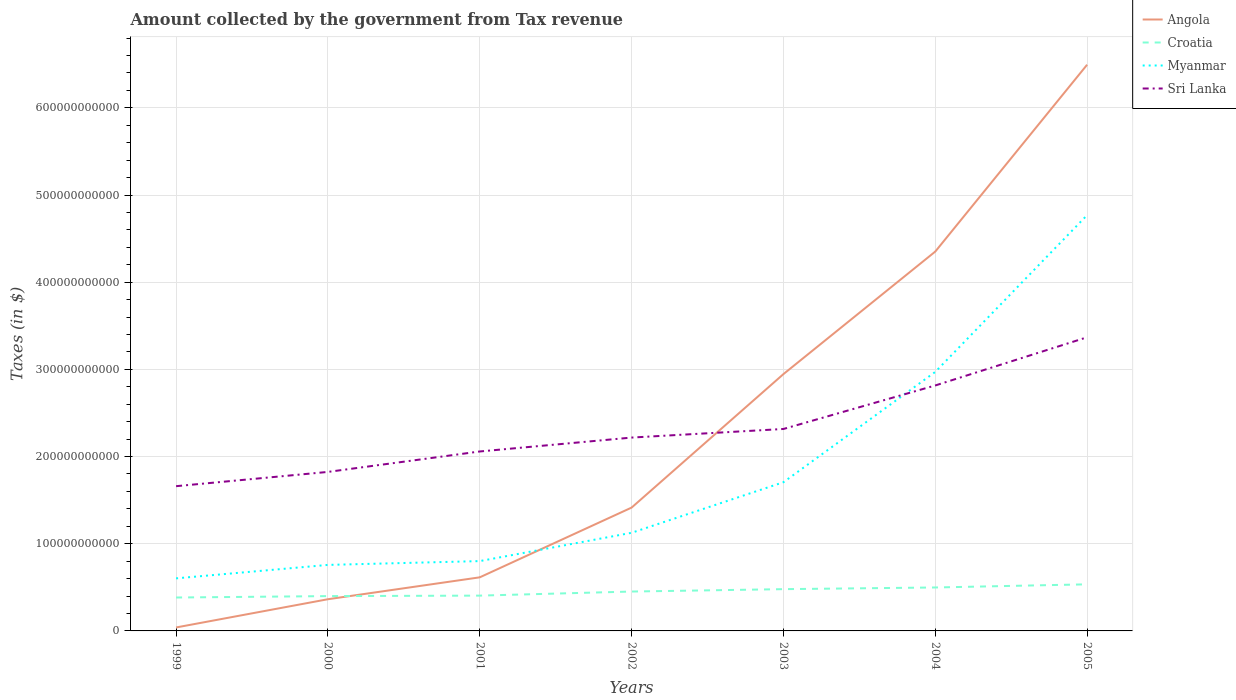How many different coloured lines are there?
Your answer should be compact. 4. Is the number of lines equal to the number of legend labels?
Offer a very short reply. Yes. Across all years, what is the maximum amount collected by the government from tax revenue in Angola?
Your answer should be compact. 3.97e+09. What is the total amount collected by the government from tax revenue in Angola in the graph?
Your answer should be very brief. -3.99e+11. What is the difference between the highest and the second highest amount collected by the government from tax revenue in Croatia?
Offer a terse response. 1.51e+1. What is the difference between the highest and the lowest amount collected by the government from tax revenue in Sri Lanka?
Provide a short and direct response. 2. Is the amount collected by the government from tax revenue in Sri Lanka strictly greater than the amount collected by the government from tax revenue in Croatia over the years?
Offer a terse response. No. How many years are there in the graph?
Make the answer very short. 7. What is the difference between two consecutive major ticks on the Y-axis?
Provide a short and direct response. 1.00e+11. Does the graph contain grids?
Give a very brief answer. Yes. How are the legend labels stacked?
Your answer should be compact. Vertical. What is the title of the graph?
Make the answer very short. Amount collected by the government from Tax revenue. Does "Norway" appear as one of the legend labels in the graph?
Offer a terse response. No. What is the label or title of the X-axis?
Make the answer very short. Years. What is the label or title of the Y-axis?
Provide a succinct answer. Taxes (in $). What is the Taxes (in $) in Angola in 1999?
Offer a terse response. 3.97e+09. What is the Taxes (in $) in Croatia in 1999?
Provide a short and direct response. 3.83e+1. What is the Taxes (in $) in Myanmar in 1999?
Make the answer very short. 6.03e+1. What is the Taxes (in $) in Sri Lanka in 1999?
Your answer should be compact. 1.66e+11. What is the Taxes (in $) of Angola in 2000?
Your answer should be compact. 3.64e+1. What is the Taxes (in $) in Croatia in 2000?
Your response must be concise. 3.99e+1. What is the Taxes (in $) in Myanmar in 2000?
Make the answer very short. 7.57e+1. What is the Taxes (in $) of Sri Lanka in 2000?
Provide a short and direct response. 1.82e+11. What is the Taxes (in $) in Angola in 2001?
Your answer should be very brief. 6.15e+1. What is the Taxes (in $) in Croatia in 2001?
Make the answer very short. 4.05e+1. What is the Taxes (in $) of Myanmar in 2001?
Give a very brief answer. 8.01e+1. What is the Taxes (in $) of Sri Lanka in 2001?
Your answer should be compact. 2.06e+11. What is the Taxes (in $) in Angola in 2002?
Provide a short and direct response. 1.41e+11. What is the Taxes (in $) of Croatia in 2002?
Offer a terse response. 4.52e+1. What is the Taxes (in $) of Myanmar in 2002?
Keep it short and to the point. 1.13e+11. What is the Taxes (in $) of Sri Lanka in 2002?
Keep it short and to the point. 2.22e+11. What is the Taxes (in $) of Angola in 2003?
Give a very brief answer. 2.95e+11. What is the Taxes (in $) of Croatia in 2003?
Your answer should be compact. 4.79e+1. What is the Taxes (in $) in Myanmar in 2003?
Make the answer very short. 1.71e+11. What is the Taxes (in $) in Sri Lanka in 2003?
Your response must be concise. 2.32e+11. What is the Taxes (in $) of Angola in 2004?
Your answer should be compact. 4.35e+11. What is the Taxes (in $) in Croatia in 2004?
Ensure brevity in your answer.  4.98e+1. What is the Taxes (in $) in Myanmar in 2004?
Your answer should be compact. 2.97e+11. What is the Taxes (in $) of Sri Lanka in 2004?
Your answer should be compact. 2.82e+11. What is the Taxes (in $) in Angola in 2005?
Provide a short and direct response. 6.49e+11. What is the Taxes (in $) in Croatia in 2005?
Your answer should be compact. 5.34e+1. What is the Taxes (in $) in Myanmar in 2005?
Give a very brief answer. 4.77e+11. What is the Taxes (in $) in Sri Lanka in 2005?
Your answer should be compact. 3.37e+11. Across all years, what is the maximum Taxes (in $) in Angola?
Offer a terse response. 6.49e+11. Across all years, what is the maximum Taxes (in $) of Croatia?
Provide a succinct answer. 5.34e+1. Across all years, what is the maximum Taxes (in $) of Myanmar?
Your answer should be very brief. 4.77e+11. Across all years, what is the maximum Taxes (in $) in Sri Lanka?
Provide a succinct answer. 3.37e+11. Across all years, what is the minimum Taxes (in $) in Angola?
Offer a very short reply. 3.97e+09. Across all years, what is the minimum Taxes (in $) in Croatia?
Ensure brevity in your answer.  3.83e+1. Across all years, what is the minimum Taxes (in $) in Myanmar?
Provide a short and direct response. 6.03e+1. Across all years, what is the minimum Taxes (in $) of Sri Lanka?
Give a very brief answer. 1.66e+11. What is the total Taxes (in $) of Angola in the graph?
Make the answer very short. 1.62e+12. What is the total Taxes (in $) in Croatia in the graph?
Provide a short and direct response. 3.15e+11. What is the total Taxes (in $) in Myanmar in the graph?
Your answer should be compact. 1.27e+12. What is the total Taxes (in $) in Sri Lanka in the graph?
Your response must be concise. 1.63e+12. What is the difference between the Taxes (in $) in Angola in 1999 and that in 2000?
Keep it short and to the point. -3.24e+1. What is the difference between the Taxes (in $) in Croatia in 1999 and that in 2000?
Your response must be concise. -1.62e+09. What is the difference between the Taxes (in $) of Myanmar in 1999 and that in 2000?
Your answer should be very brief. -1.54e+1. What is the difference between the Taxes (in $) of Sri Lanka in 1999 and that in 2000?
Keep it short and to the point. -1.64e+1. What is the difference between the Taxes (in $) in Angola in 1999 and that in 2001?
Give a very brief answer. -5.75e+1. What is the difference between the Taxes (in $) of Croatia in 1999 and that in 2001?
Offer a terse response. -2.17e+09. What is the difference between the Taxes (in $) in Myanmar in 1999 and that in 2001?
Your answer should be very brief. -1.98e+1. What is the difference between the Taxes (in $) of Sri Lanka in 1999 and that in 2001?
Offer a terse response. -3.98e+1. What is the difference between the Taxes (in $) of Angola in 1999 and that in 2002?
Offer a terse response. -1.38e+11. What is the difference between the Taxes (in $) of Croatia in 1999 and that in 2002?
Provide a succinct answer. -6.85e+09. What is the difference between the Taxes (in $) in Myanmar in 1999 and that in 2002?
Give a very brief answer. -5.23e+1. What is the difference between the Taxes (in $) in Sri Lanka in 1999 and that in 2002?
Offer a terse response. -5.58e+1. What is the difference between the Taxes (in $) of Angola in 1999 and that in 2003?
Your response must be concise. -2.91e+11. What is the difference between the Taxes (in $) in Croatia in 1999 and that in 2003?
Provide a succinct answer. -9.59e+09. What is the difference between the Taxes (in $) in Myanmar in 1999 and that in 2003?
Provide a short and direct response. -1.10e+11. What is the difference between the Taxes (in $) of Sri Lanka in 1999 and that in 2003?
Give a very brief answer. -6.56e+1. What is the difference between the Taxes (in $) of Angola in 1999 and that in 2004?
Offer a very short reply. -4.31e+11. What is the difference between the Taxes (in $) in Croatia in 1999 and that in 2004?
Keep it short and to the point. -1.15e+1. What is the difference between the Taxes (in $) in Myanmar in 1999 and that in 2004?
Give a very brief answer. -2.37e+11. What is the difference between the Taxes (in $) in Sri Lanka in 1999 and that in 2004?
Provide a short and direct response. -1.16e+11. What is the difference between the Taxes (in $) in Angola in 1999 and that in 2005?
Ensure brevity in your answer.  -6.46e+11. What is the difference between the Taxes (in $) of Croatia in 1999 and that in 2005?
Keep it short and to the point. -1.51e+1. What is the difference between the Taxes (in $) of Myanmar in 1999 and that in 2005?
Keep it short and to the point. -4.17e+11. What is the difference between the Taxes (in $) in Sri Lanka in 1999 and that in 2005?
Offer a terse response. -1.71e+11. What is the difference between the Taxes (in $) in Angola in 2000 and that in 2001?
Provide a succinct answer. -2.51e+1. What is the difference between the Taxes (in $) in Croatia in 2000 and that in 2001?
Offer a very short reply. -5.53e+08. What is the difference between the Taxes (in $) of Myanmar in 2000 and that in 2001?
Offer a terse response. -4.37e+09. What is the difference between the Taxes (in $) of Sri Lanka in 2000 and that in 2001?
Keep it short and to the point. -2.34e+1. What is the difference between the Taxes (in $) in Angola in 2000 and that in 2002?
Provide a succinct answer. -1.05e+11. What is the difference between the Taxes (in $) in Croatia in 2000 and that in 2002?
Ensure brevity in your answer.  -5.23e+09. What is the difference between the Taxes (in $) in Myanmar in 2000 and that in 2002?
Give a very brief answer. -3.68e+1. What is the difference between the Taxes (in $) in Sri Lanka in 2000 and that in 2002?
Ensure brevity in your answer.  -3.94e+1. What is the difference between the Taxes (in $) of Angola in 2000 and that in 2003?
Keep it short and to the point. -2.58e+11. What is the difference between the Taxes (in $) in Croatia in 2000 and that in 2003?
Your answer should be very brief. -7.97e+09. What is the difference between the Taxes (in $) in Myanmar in 2000 and that in 2003?
Provide a succinct answer. -9.48e+1. What is the difference between the Taxes (in $) in Sri Lanka in 2000 and that in 2003?
Keep it short and to the point. -4.93e+1. What is the difference between the Taxes (in $) in Angola in 2000 and that in 2004?
Your response must be concise. -3.99e+11. What is the difference between the Taxes (in $) in Croatia in 2000 and that in 2004?
Your answer should be compact. -9.89e+09. What is the difference between the Taxes (in $) of Myanmar in 2000 and that in 2004?
Provide a succinct answer. -2.21e+11. What is the difference between the Taxes (in $) of Sri Lanka in 2000 and that in 2004?
Offer a terse response. -9.92e+1. What is the difference between the Taxes (in $) in Angola in 2000 and that in 2005?
Make the answer very short. -6.13e+11. What is the difference between the Taxes (in $) of Croatia in 2000 and that in 2005?
Offer a terse response. -1.35e+1. What is the difference between the Taxes (in $) in Myanmar in 2000 and that in 2005?
Ensure brevity in your answer.  -4.01e+11. What is the difference between the Taxes (in $) of Sri Lanka in 2000 and that in 2005?
Give a very brief answer. -1.54e+11. What is the difference between the Taxes (in $) in Angola in 2001 and that in 2002?
Offer a terse response. -8.00e+1. What is the difference between the Taxes (in $) in Croatia in 2001 and that in 2002?
Keep it short and to the point. -4.68e+09. What is the difference between the Taxes (in $) of Myanmar in 2001 and that in 2002?
Keep it short and to the point. -3.25e+1. What is the difference between the Taxes (in $) in Sri Lanka in 2001 and that in 2002?
Ensure brevity in your answer.  -1.59e+1. What is the difference between the Taxes (in $) in Angola in 2001 and that in 2003?
Your answer should be very brief. -2.33e+11. What is the difference between the Taxes (in $) in Croatia in 2001 and that in 2003?
Provide a short and direct response. -7.42e+09. What is the difference between the Taxes (in $) of Myanmar in 2001 and that in 2003?
Your answer should be compact. -9.05e+1. What is the difference between the Taxes (in $) in Sri Lanka in 2001 and that in 2003?
Your answer should be very brief. -2.58e+1. What is the difference between the Taxes (in $) in Angola in 2001 and that in 2004?
Make the answer very short. -3.74e+11. What is the difference between the Taxes (in $) of Croatia in 2001 and that in 2004?
Your answer should be compact. -9.34e+09. What is the difference between the Taxes (in $) in Myanmar in 2001 and that in 2004?
Your answer should be compact. -2.17e+11. What is the difference between the Taxes (in $) of Sri Lanka in 2001 and that in 2004?
Give a very brief answer. -7.57e+1. What is the difference between the Taxes (in $) of Angola in 2001 and that in 2005?
Keep it short and to the point. -5.88e+11. What is the difference between the Taxes (in $) in Croatia in 2001 and that in 2005?
Ensure brevity in your answer.  -1.30e+1. What is the difference between the Taxes (in $) of Myanmar in 2001 and that in 2005?
Your answer should be very brief. -3.97e+11. What is the difference between the Taxes (in $) of Sri Lanka in 2001 and that in 2005?
Your answer should be very brief. -1.31e+11. What is the difference between the Taxes (in $) of Angola in 2002 and that in 2003?
Keep it short and to the point. -1.53e+11. What is the difference between the Taxes (in $) in Croatia in 2002 and that in 2003?
Your response must be concise. -2.74e+09. What is the difference between the Taxes (in $) in Myanmar in 2002 and that in 2003?
Ensure brevity in your answer.  -5.80e+1. What is the difference between the Taxes (in $) of Sri Lanka in 2002 and that in 2003?
Your response must be concise. -9.86e+09. What is the difference between the Taxes (in $) of Angola in 2002 and that in 2004?
Ensure brevity in your answer.  -2.94e+11. What is the difference between the Taxes (in $) in Croatia in 2002 and that in 2004?
Provide a succinct answer. -4.66e+09. What is the difference between the Taxes (in $) in Myanmar in 2002 and that in 2004?
Provide a succinct answer. -1.85e+11. What is the difference between the Taxes (in $) in Sri Lanka in 2002 and that in 2004?
Your answer should be compact. -5.98e+1. What is the difference between the Taxes (in $) in Angola in 2002 and that in 2005?
Offer a very short reply. -5.08e+11. What is the difference between the Taxes (in $) of Croatia in 2002 and that in 2005?
Offer a terse response. -8.28e+09. What is the difference between the Taxes (in $) of Myanmar in 2002 and that in 2005?
Offer a very short reply. -3.64e+11. What is the difference between the Taxes (in $) of Sri Lanka in 2002 and that in 2005?
Your answer should be very brief. -1.15e+11. What is the difference between the Taxes (in $) in Angola in 2003 and that in 2004?
Give a very brief answer. -1.41e+11. What is the difference between the Taxes (in $) in Croatia in 2003 and that in 2004?
Make the answer very short. -1.92e+09. What is the difference between the Taxes (in $) in Myanmar in 2003 and that in 2004?
Your answer should be very brief. -1.27e+11. What is the difference between the Taxes (in $) in Sri Lanka in 2003 and that in 2004?
Your answer should be very brief. -4.99e+1. What is the difference between the Taxes (in $) in Angola in 2003 and that in 2005?
Ensure brevity in your answer.  -3.55e+11. What is the difference between the Taxes (in $) of Croatia in 2003 and that in 2005?
Keep it short and to the point. -5.54e+09. What is the difference between the Taxes (in $) in Myanmar in 2003 and that in 2005?
Provide a short and direct response. -3.06e+11. What is the difference between the Taxes (in $) of Sri Lanka in 2003 and that in 2005?
Offer a terse response. -1.05e+11. What is the difference between the Taxes (in $) in Angola in 2004 and that in 2005?
Offer a terse response. -2.14e+11. What is the difference between the Taxes (in $) of Croatia in 2004 and that in 2005?
Keep it short and to the point. -3.62e+09. What is the difference between the Taxes (in $) in Myanmar in 2004 and that in 2005?
Provide a succinct answer. -1.80e+11. What is the difference between the Taxes (in $) of Sri Lanka in 2004 and that in 2005?
Your answer should be compact. -5.53e+1. What is the difference between the Taxes (in $) in Angola in 1999 and the Taxes (in $) in Croatia in 2000?
Keep it short and to the point. -3.60e+1. What is the difference between the Taxes (in $) of Angola in 1999 and the Taxes (in $) of Myanmar in 2000?
Offer a very short reply. -7.18e+1. What is the difference between the Taxes (in $) in Angola in 1999 and the Taxes (in $) in Sri Lanka in 2000?
Offer a very short reply. -1.78e+11. What is the difference between the Taxes (in $) in Croatia in 1999 and the Taxes (in $) in Myanmar in 2000?
Your answer should be very brief. -3.74e+1. What is the difference between the Taxes (in $) of Croatia in 1999 and the Taxes (in $) of Sri Lanka in 2000?
Make the answer very short. -1.44e+11. What is the difference between the Taxes (in $) of Myanmar in 1999 and the Taxes (in $) of Sri Lanka in 2000?
Give a very brief answer. -1.22e+11. What is the difference between the Taxes (in $) in Angola in 1999 and the Taxes (in $) in Croatia in 2001?
Your answer should be very brief. -3.65e+1. What is the difference between the Taxes (in $) of Angola in 1999 and the Taxes (in $) of Myanmar in 2001?
Keep it short and to the point. -7.61e+1. What is the difference between the Taxes (in $) of Angola in 1999 and the Taxes (in $) of Sri Lanka in 2001?
Offer a terse response. -2.02e+11. What is the difference between the Taxes (in $) in Croatia in 1999 and the Taxes (in $) in Myanmar in 2001?
Offer a terse response. -4.18e+1. What is the difference between the Taxes (in $) of Croatia in 1999 and the Taxes (in $) of Sri Lanka in 2001?
Make the answer very short. -1.68e+11. What is the difference between the Taxes (in $) in Myanmar in 1999 and the Taxes (in $) in Sri Lanka in 2001?
Your response must be concise. -1.46e+11. What is the difference between the Taxes (in $) of Angola in 1999 and the Taxes (in $) of Croatia in 2002?
Make the answer very short. -4.12e+1. What is the difference between the Taxes (in $) in Angola in 1999 and the Taxes (in $) in Myanmar in 2002?
Ensure brevity in your answer.  -1.09e+11. What is the difference between the Taxes (in $) of Angola in 1999 and the Taxes (in $) of Sri Lanka in 2002?
Ensure brevity in your answer.  -2.18e+11. What is the difference between the Taxes (in $) of Croatia in 1999 and the Taxes (in $) of Myanmar in 2002?
Keep it short and to the point. -7.42e+1. What is the difference between the Taxes (in $) in Croatia in 1999 and the Taxes (in $) in Sri Lanka in 2002?
Provide a succinct answer. -1.83e+11. What is the difference between the Taxes (in $) in Myanmar in 1999 and the Taxes (in $) in Sri Lanka in 2002?
Offer a very short reply. -1.61e+11. What is the difference between the Taxes (in $) of Angola in 1999 and the Taxes (in $) of Croatia in 2003?
Your answer should be very brief. -4.39e+1. What is the difference between the Taxes (in $) in Angola in 1999 and the Taxes (in $) in Myanmar in 2003?
Your response must be concise. -1.67e+11. What is the difference between the Taxes (in $) of Angola in 1999 and the Taxes (in $) of Sri Lanka in 2003?
Ensure brevity in your answer.  -2.28e+11. What is the difference between the Taxes (in $) in Croatia in 1999 and the Taxes (in $) in Myanmar in 2003?
Your answer should be very brief. -1.32e+11. What is the difference between the Taxes (in $) in Croatia in 1999 and the Taxes (in $) in Sri Lanka in 2003?
Your answer should be very brief. -1.93e+11. What is the difference between the Taxes (in $) of Myanmar in 1999 and the Taxes (in $) of Sri Lanka in 2003?
Your answer should be very brief. -1.71e+11. What is the difference between the Taxes (in $) of Angola in 1999 and the Taxes (in $) of Croatia in 2004?
Your response must be concise. -4.59e+1. What is the difference between the Taxes (in $) in Angola in 1999 and the Taxes (in $) in Myanmar in 2004?
Your response must be concise. -2.93e+11. What is the difference between the Taxes (in $) in Angola in 1999 and the Taxes (in $) in Sri Lanka in 2004?
Your response must be concise. -2.78e+11. What is the difference between the Taxes (in $) in Croatia in 1999 and the Taxes (in $) in Myanmar in 2004?
Your answer should be very brief. -2.59e+11. What is the difference between the Taxes (in $) of Croatia in 1999 and the Taxes (in $) of Sri Lanka in 2004?
Keep it short and to the point. -2.43e+11. What is the difference between the Taxes (in $) of Myanmar in 1999 and the Taxes (in $) of Sri Lanka in 2004?
Offer a terse response. -2.21e+11. What is the difference between the Taxes (in $) in Angola in 1999 and the Taxes (in $) in Croatia in 2005?
Offer a terse response. -4.95e+1. What is the difference between the Taxes (in $) in Angola in 1999 and the Taxes (in $) in Myanmar in 2005?
Provide a succinct answer. -4.73e+11. What is the difference between the Taxes (in $) of Angola in 1999 and the Taxes (in $) of Sri Lanka in 2005?
Provide a succinct answer. -3.33e+11. What is the difference between the Taxes (in $) of Croatia in 1999 and the Taxes (in $) of Myanmar in 2005?
Offer a very short reply. -4.39e+11. What is the difference between the Taxes (in $) in Croatia in 1999 and the Taxes (in $) in Sri Lanka in 2005?
Provide a succinct answer. -2.99e+11. What is the difference between the Taxes (in $) in Myanmar in 1999 and the Taxes (in $) in Sri Lanka in 2005?
Make the answer very short. -2.77e+11. What is the difference between the Taxes (in $) in Angola in 2000 and the Taxes (in $) in Croatia in 2001?
Offer a very short reply. -4.14e+09. What is the difference between the Taxes (in $) of Angola in 2000 and the Taxes (in $) of Myanmar in 2001?
Offer a very short reply. -4.37e+1. What is the difference between the Taxes (in $) of Angola in 2000 and the Taxes (in $) of Sri Lanka in 2001?
Offer a terse response. -1.69e+11. What is the difference between the Taxes (in $) of Croatia in 2000 and the Taxes (in $) of Myanmar in 2001?
Offer a terse response. -4.02e+1. What is the difference between the Taxes (in $) in Croatia in 2000 and the Taxes (in $) in Sri Lanka in 2001?
Make the answer very short. -1.66e+11. What is the difference between the Taxes (in $) of Myanmar in 2000 and the Taxes (in $) of Sri Lanka in 2001?
Give a very brief answer. -1.30e+11. What is the difference between the Taxes (in $) in Angola in 2000 and the Taxes (in $) in Croatia in 2002?
Make the answer very short. -8.82e+09. What is the difference between the Taxes (in $) of Angola in 2000 and the Taxes (in $) of Myanmar in 2002?
Your answer should be very brief. -7.62e+1. What is the difference between the Taxes (in $) in Angola in 2000 and the Taxes (in $) in Sri Lanka in 2002?
Your answer should be compact. -1.85e+11. What is the difference between the Taxes (in $) in Croatia in 2000 and the Taxes (in $) in Myanmar in 2002?
Offer a very short reply. -7.26e+1. What is the difference between the Taxes (in $) in Croatia in 2000 and the Taxes (in $) in Sri Lanka in 2002?
Provide a short and direct response. -1.82e+11. What is the difference between the Taxes (in $) of Myanmar in 2000 and the Taxes (in $) of Sri Lanka in 2002?
Give a very brief answer. -1.46e+11. What is the difference between the Taxes (in $) of Angola in 2000 and the Taxes (in $) of Croatia in 2003?
Offer a very short reply. -1.16e+1. What is the difference between the Taxes (in $) of Angola in 2000 and the Taxes (in $) of Myanmar in 2003?
Make the answer very short. -1.34e+11. What is the difference between the Taxes (in $) of Angola in 2000 and the Taxes (in $) of Sri Lanka in 2003?
Your response must be concise. -1.95e+11. What is the difference between the Taxes (in $) in Croatia in 2000 and the Taxes (in $) in Myanmar in 2003?
Offer a very short reply. -1.31e+11. What is the difference between the Taxes (in $) in Croatia in 2000 and the Taxes (in $) in Sri Lanka in 2003?
Provide a succinct answer. -1.92e+11. What is the difference between the Taxes (in $) in Myanmar in 2000 and the Taxes (in $) in Sri Lanka in 2003?
Give a very brief answer. -1.56e+11. What is the difference between the Taxes (in $) in Angola in 2000 and the Taxes (in $) in Croatia in 2004?
Offer a terse response. -1.35e+1. What is the difference between the Taxes (in $) of Angola in 2000 and the Taxes (in $) of Myanmar in 2004?
Offer a very short reply. -2.61e+11. What is the difference between the Taxes (in $) in Angola in 2000 and the Taxes (in $) in Sri Lanka in 2004?
Provide a succinct answer. -2.45e+11. What is the difference between the Taxes (in $) in Croatia in 2000 and the Taxes (in $) in Myanmar in 2004?
Keep it short and to the point. -2.57e+11. What is the difference between the Taxes (in $) in Croatia in 2000 and the Taxes (in $) in Sri Lanka in 2004?
Make the answer very short. -2.42e+11. What is the difference between the Taxes (in $) of Myanmar in 2000 and the Taxes (in $) of Sri Lanka in 2004?
Make the answer very short. -2.06e+11. What is the difference between the Taxes (in $) of Angola in 2000 and the Taxes (in $) of Croatia in 2005?
Offer a terse response. -1.71e+1. What is the difference between the Taxes (in $) of Angola in 2000 and the Taxes (in $) of Myanmar in 2005?
Give a very brief answer. -4.41e+11. What is the difference between the Taxes (in $) in Angola in 2000 and the Taxes (in $) in Sri Lanka in 2005?
Provide a short and direct response. -3.00e+11. What is the difference between the Taxes (in $) in Croatia in 2000 and the Taxes (in $) in Myanmar in 2005?
Your answer should be compact. -4.37e+11. What is the difference between the Taxes (in $) in Croatia in 2000 and the Taxes (in $) in Sri Lanka in 2005?
Your answer should be very brief. -2.97e+11. What is the difference between the Taxes (in $) in Myanmar in 2000 and the Taxes (in $) in Sri Lanka in 2005?
Ensure brevity in your answer.  -2.61e+11. What is the difference between the Taxes (in $) in Angola in 2001 and the Taxes (in $) in Croatia in 2002?
Offer a terse response. 1.63e+1. What is the difference between the Taxes (in $) of Angola in 2001 and the Taxes (in $) of Myanmar in 2002?
Offer a very short reply. -5.11e+1. What is the difference between the Taxes (in $) in Angola in 2001 and the Taxes (in $) in Sri Lanka in 2002?
Offer a very short reply. -1.60e+11. What is the difference between the Taxes (in $) in Croatia in 2001 and the Taxes (in $) in Myanmar in 2002?
Keep it short and to the point. -7.21e+1. What is the difference between the Taxes (in $) of Croatia in 2001 and the Taxes (in $) of Sri Lanka in 2002?
Provide a short and direct response. -1.81e+11. What is the difference between the Taxes (in $) in Myanmar in 2001 and the Taxes (in $) in Sri Lanka in 2002?
Offer a very short reply. -1.42e+11. What is the difference between the Taxes (in $) of Angola in 2001 and the Taxes (in $) of Croatia in 2003?
Ensure brevity in your answer.  1.36e+1. What is the difference between the Taxes (in $) of Angola in 2001 and the Taxes (in $) of Myanmar in 2003?
Your response must be concise. -1.09e+11. What is the difference between the Taxes (in $) of Angola in 2001 and the Taxes (in $) of Sri Lanka in 2003?
Your answer should be very brief. -1.70e+11. What is the difference between the Taxes (in $) of Croatia in 2001 and the Taxes (in $) of Myanmar in 2003?
Your response must be concise. -1.30e+11. What is the difference between the Taxes (in $) in Croatia in 2001 and the Taxes (in $) in Sri Lanka in 2003?
Your response must be concise. -1.91e+11. What is the difference between the Taxes (in $) of Myanmar in 2001 and the Taxes (in $) of Sri Lanka in 2003?
Your response must be concise. -1.52e+11. What is the difference between the Taxes (in $) in Angola in 2001 and the Taxes (in $) in Croatia in 2004?
Your response must be concise. 1.16e+1. What is the difference between the Taxes (in $) in Angola in 2001 and the Taxes (in $) in Myanmar in 2004?
Keep it short and to the point. -2.36e+11. What is the difference between the Taxes (in $) in Angola in 2001 and the Taxes (in $) in Sri Lanka in 2004?
Make the answer very short. -2.20e+11. What is the difference between the Taxes (in $) of Croatia in 2001 and the Taxes (in $) of Myanmar in 2004?
Give a very brief answer. -2.57e+11. What is the difference between the Taxes (in $) in Croatia in 2001 and the Taxes (in $) in Sri Lanka in 2004?
Ensure brevity in your answer.  -2.41e+11. What is the difference between the Taxes (in $) of Myanmar in 2001 and the Taxes (in $) of Sri Lanka in 2004?
Make the answer very short. -2.01e+11. What is the difference between the Taxes (in $) in Angola in 2001 and the Taxes (in $) in Croatia in 2005?
Make the answer very short. 8.03e+09. What is the difference between the Taxes (in $) of Angola in 2001 and the Taxes (in $) of Myanmar in 2005?
Your answer should be very brief. -4.15e+11. What is the difference between the Taxes (in $) of Angola in 2001 and the Taxes (in $) of Sri Lanka in 2005?
Keep it short and to the point. -2.75e+11. What is the difference between the Taxes (in $) of Croatia in 2001 and the Taxes (in $) of Myanmar in 2005?
Your answer should be compact. -4.36e+11. What is the difference between the Taxes (in $) of Croatia in 2001 and the Taxes (in $) of Sri Lanka in 2005?
Offer a terse response. -2.96e+11. What is the difference between the Taxes (in $) of Myanmar in 2001 and the Taxes (in $) of Sri Lanka in 2005?
Offer a very short reply. -2.57e+11. What is the difference between the Taxes (in $) in Angola in 2002 and the Taxes (in $) in Croatia in 2003?
Your answer should be compact. 9.36e+1. What is the difference between the Taxes (in $) in Angola in 2002 and the Taxes (in $) in Myanmar in 2003?
Offer a very short reply. -2.91e+1. What is the difference between the Taxes (in $) in Angola in 2002 and the Taxes (in $) in Sri Lanka in 2003?
Your response must be concise. -9.02e+1. What is the difference between the Taxes (in $) of Croatia in 2002 and the Taxes (in $) of Myanmar in 2003?
Your response must be concise. -1.25e+11. What is the difference between the Taxes (in $) in Croatia in 2002 and the Taxes (in $) in Sri Lanka in 2003?
Offer a very short reply. -1.86e+11. What is the difference between the Taxes (in $) of Myanmar in 2002 and the Taxes (in $) of Sri Lanka in 2003?
Provide a succinct answer. -1.19e+11. What is the difference between the Taxes (in $) of Angola in 2002 and the Taxes (in $) of Croatia in 2004?
Make the answer very short. 9.16e+1. What is the difference between the Taxes (in $) in Angola in 2002 and the Taxes (in $) in Myanmar in 2004?
Give a very brief answer. -1.56e+11. What is the difference between the Taxes (in $) in Angola in 2002 and the Taxes (in $) in Sri Lanka in 2004?
Your answer should be very brief. -1.40e+11. What is the difference between the Taxes (in $) in Croatia in 2002 and the Taxes (in $) in Myanmar in 2004?
Your response must be concise. -2.52e+11. What is the difference between the Taxes (in $) in Croatia in 2002 and the Taxes (in $) in Sri Lanka in 2004?
Ensure brevity in your answer.  -2.36e+11. What is the difference between the Taxes (in $) in Myanmar in 2002 and the Taxes (in $) in Sri Lanka in 2004?
Provide a short and direct response. -1.69e+11. What is the difference between the Taxes (in $) of Angola in 2002 and the Taxes (in $) of Croatia in 2005?
Your answer should be compact. 8.80e+1. What is the difference between the Taxes (in $) in Angola in 2002 and the Taxes (in $) in Myanmar in 2005?
Your answer should be compact. -3.35e+11. What is the difference between the Taxes (in $) of Angola in 2002 and the Taxes (in $) of Sri Lanka in 2005?
Give a very brief answer. -1.95e+11. What is the difference between the Taxes (in $) of Croatia in 2002 and the Taxes (in $) of Myanmar in 2005?
Your answer should be very brief. -4.32e+11. What is the difference between the Taxes (in $) in Croatia in 2002 and the Taxes (in $) in Sri Lanka in 2005?
Your answer should be compact. -2.92e+11. What is the difference between the Taxes (in $) of Myanmar in 2002 and the Taxes (in $) of Sri Lanka in 2005?
Offer a very short reply. -2.24e+11. What is the difference between the Taxes (in $) of Angola in 2003 and the Taxes (in $) of Croatia in 2004?
Your response must be concise. 2.45e+11. What is the difference between the Taxes (in $) in Angola in 2003 and the Taxes (in $) in Myanmar in 2004?
Provide a succinct answer. -2.51e+09. What is the difference between the Taxes (in $) of Angola in 2003 and the Taxes (in $) of Sri Lanka in 2004?
Ensure brevity in your answer.  1.30e+1. What is the difference between the Taxes (in $) in Croatia in 2003 and the Taxes (in $) in Myanmar in 2004?
Your response must be concise. -2.49e+11. What is the difference between the Taxes (in $) in Croatia in 2003 and the Taxes (in $) in Sri Lanka in 2004?
Ensure brevity in your answer.  -2.34e+11. What is the difference between the Taxes (in $) in Myanmar in 2003 and the Taxes (in $) in Sri Lanka in 2004?
Provide a succinct answer. -1.11e+11. What is the difference between the Taxes (in $) in Angola in 2003 and the Taxes (in $) in Croatia in 2005?
Your answer should be compact. 2.41e+11. What is the difference between the Taxes (in $) of Angola in 2003 and the Taxes (in $) of Myanmar in 2005?
Provide a succinct answer. -1.82e+11. What is the difference between the Taxes (in $) of Angola in 2003 and the Taxes (in $) of Sri Lanka in 2005?
Offer a very short reply. -4.22e+1. What is the difference between the Taxes (in $) of Croatia in 2003 and the Taxes (in $) of Myanmar in 2005?
Offer a terse response. -4.29e+11. What is the difference between the Taxes (in $) in Croatia in 2003 and the Taxes (in $) in Sri Lanka in 2005?
Make the answer very short. -2.89e+11. What is the difference between the Taxes (in $) of Myanmar in 2003 and the Taxes (in $) of Sri Lanka in 2005?
Give a very brief answer. -1.66e+11. What is the difference between the Taxes (in $) in Angola in 2004 and the Taxes (in $) in Croatia in 2005?
Give a very brief answer. 3.82e+11. What is the difference between the Taxes (in $) in Angola in 2004 and the Taxes (in $) in Myanmar in 2005?
Your response must be concise. -4.18e+1. What is the difference between the Taxes (in $) in Angola in 2004 and the Taxes (in $) in Sri Lanka in 2005?
Your answer should be very brief. 9.83e+1. What is the difference between the Taxes (in $) of Croatia in 2004 and the Taxes (in $) of Myanmar in 2005?
Provide a succinct answer. -4.27e+11. What is the difference between the Taxes (in $) of Croatia in 2004 and the Taxes (in $) of Sri Lanka in 2005?
Give a very brief answer. -2.87e+11. What is the difference between the Taxes (in $) of Myanmar in 2004 and the Taxes (in $) of Sri Lanka in 2005?
Your answer should be very brief. -3.97e+1. What is the average Taxes (in $) of Angola per year?
Keep it short and to the point. 2.32e+11. What is the average Taxes (in $) of Croatia per year?
Keep it short and to the point. 4.50e+1. What is the average Taxes (in $) in Myanmar per year?
Ensure brevity in your answer.  1.82e+11. What is the average Taxes (in $) in Sri Lanka per year?
Your answer should be compact. 2.32e+11. In the year 1999, what is the difference between the Taxes (in $) of Angola and Taxes (in $) of Croatia?
Your answer should be compact. -3.43e+1. In the year 1999, what is the difference between the Taxes (in $) in Angola and Taxes (in $) in Myanmar?
Provide a short and direct response. -5.63e+1. In the year 1999, what is the difference between the Taxes (in $) in Angola and Taxes (in $) in Sri Lanka?
Offer a very short reply. -1.62e+11. In the year 1999, what is the difference between the Taxes (in $) of Croatia and Taxes (in $) of Myanmar?
Your answer should be compact. -2.20e+1. In the year 1999, what is the difference between the Taxes (in $) of Croatia and Taxes (in $) of Sri Lanka?
Offer a very short reply. -1.28e+11. In the year 1999, what is the difference between the Taxes (in $) in Myanmar and Taxes (in $) in Sri Lanka?
Your response must be concise. -1.06e+11. In the year 2000, what is the difference between the Taxes (in $) in Angola and Taxes (in $) in Croatia?
Provide a succinct answer. -3.58e+09. In the year 2000, what is the difference between the Taxes (in $) of Angola and Taxes (in $) of Myanmar?
Keep it short and to the point. -3.94e+1. In the year 2000, what is the difference between the Taxes (in $) in Angola and Taxes (in $) in Sri Lanka?
Your answer should be compact. -1.46e+11. In the year 2000, what is the difference between the Taxes (in $) of Croatia and Taxes (in $) of Myanmar?
Offer a very short reply. -3.58e+1. In the year 2000, what is the difference between the Taxes (in $) of Croatia and Taxes (in $) of Sri Lanka?
Give a very brief answer. -1.42e+11. In the year 2000, what is the difference between the Taxes (in $) in Myanmar and Taxes (in $) in Sri Lanka?
Ensure brevity in your answer.  -1.07e+11. In the year 2001, what is the difference between the Taxes (in $) of Angola and Taxes (in $) of Croatia?
Give a very brief answer. 2.10e+1. In the year 2001, what is the difference between the Taxes (in $) of Angola and Taxes (in $) of Myanmar?
Your answer should be compact. -1.86e+1. In the year 2001, what is the difference between the Taxes (in $) in Angola and Taxes (in $) in Sri Lanka?
Provide a short and direct response. -1.44e+11. In the year 2001, what is the difference between the Taxes (in $) in Croatia and Taxes (in $) in Myanmar?
Provide a short and direct response. -3.96e+1. In the year 2001, what is the difference between the Taxes (in $) in Croatia and Taxes (in $) in Sri Lanka?
Make the answer very short. -1.65e+11. In the year 2001, what is the difference between the Taxes (in $) in Myanmar and Taxes (in $) in Sri Lanka?
Make the answer very short. -1.26e+11. In the year 2002, what is the difference between the Taxes (in $) of Angola and Taxes (in $) of Croatia?
Your answer should be compact. 9.63e+1. In the year 2002, what is the difference between the Taxes (in $) in Angola and Taxes (in $) in Myanmar?
Keep it short and to the point. 2.89e+1. In the year 2002, what is the difference between the Taxes (in $) of Angola and Taxes (in $) of Sri Lanka?
Keep it short and to the point. -8.03e+1. In the year 2002, what is the difference between the Taxes (in $) of Croatia and Taxes (in $) of Myanmar?
Keep it short and to the point. -6.74e+1. In the year 2002, what is the difference between the Taxes (in $) in Croatia and Taxes (in $) in Sri Lanka?
Your answer should be very brief. -1.77e+11. In the year 2002, what is the difference between the Taxes (in $) in Myanmar and Taxes (in $) in Sri Lanka?
Offer a terse response. -1.09e+11. In the year 2003, what is the difference between the Taxes (in $) of Angola and Taxes (in $) of Croatia?
Your answer should be very brief. 2.47e+11. In the year 2003, what is the difference between the Taxes (in $) in Angola and Taxes (in $) in Myanmar?
Offer a terse response. 1.24e+11. In the year 2003, what is the difference between the Taxes (in $) in Angola and Taxes (in $) in Sri Lanka?
Provide a succinct answer. 6.29e+1. In the year 2003, what is the difference between the Taxes (in $) in Croatia and Taxes (in $) in Myanmar?
Your response must be concise. -1.23e+11. In the year 2003, what is the difference between the Taxes (in $) of Croatia and Taxes (in $) of Sri Lanka?
Your answer should be very brief. -1.84e+11. In the year 2003, what is the difference between the Taxes (in $) of Myanmar and Taxes (in $) of Sri Lanka?
Make the answer very short. -6.11e+1. In the year 2004, what is the difference between the Taxes (in $) of Angola and Taxes (in $) of Croatia?
Give a very brief answer. 3.85e+11. In the year 2004, what is the difference between the Taxes (in $) in Angola and Taxes (in $) in Myanmar?
Keep it short and to the point. 1.38e+11. In the year 2004, what is the difference between the Taxes (in $) in Angola and Taxes (in $) in Sri Lanka?
Your answer should be very brief. 1.54e+11. In the year 2004, what is the difference between the Taxes (in $) of Croatia and Taxes (in $) of Myanmar?
Give a very brief answer. -2.47e+11. In the year 2004, what is the difference between the Taxes (in $) of Croatia and Taxes (in $) of Sri Lanka?
Your answer should be compact. -2.32e+11. In the year 2004, what is the difference between the Taxes (in $) in Myanmar and Taxes (in $) in Sri Lanka?
Provide a succinct answer. 1.56e+1. In the year 2005, what is the difference between the Taxes (in $) of Angola and Taxes (in $) of Croatia?
Your response must be concise. 5.96e+11. In the year 2005, what is the difference between the Taxes (in $) in Angola and Taxes (in $) in Myanmar?
Provide a short and direct response. 1.73e+11. In the year 2005, what is the difference between the Taxes (in $) in Angola and Taxes (in $) in Sri Lanka?
Provide a short and direct response. 3.13e+11. In the year 2005, what is the difference between the Taxes (in $) of Croatia and Taxes (in $) of Myanmar?
Your answer should be compact. -4.23e+11. In the year 2005, what is the difference between the Taxes (in $) in Croatia and Taxes (in $) in Sri Lanka?
Make the answer very short. -2.83e+11. In the year 2005, what is the difference between the Taxes (in $) of Myanmar and Taxes (in $) of Sri Lanka?
Your response must be concise. 1.40e+11. What is the ratio of the Taxes (in $) in Angola in 1999 to that in 2000?
Ensure brevity in your answer.  0.11. What is the ratio of the Taxes (in $) in Croatia in 1999 to that in 2000?
Your answer should be compact. 0.96. What is the ratio of the Taxes (in $) of Myanmar in 1999 to that in 2000?
Provide a short and direct response. 0.8. What is the ratio of the Taxes (in $) of Sri Lanka in 1999 to that in 2000?
Give a very brief answer. 0.91. What is the ratio of the Taxes (in $) in Angola in 1999 to that in 2001?
Provide a succinct answer. 0.06. What is the ratio of the Taxes (in $) of Croatia in 1999 to that in 2001?
Your answer should be compact. 0.95. What is the ratio of the Taxes (in $) in Myanmar in 1999 to that in 2001?
Your response must be concise. 0.75. What is the ratio of the Taxes (in $) in Sri Lanka in 1999 to that in 2001?
Your answer should be compact. 0.81. What is the ratio of the Taxes (in $) in Angola in 1999 to that in 2002?
Ensure brevity in your answer.  0.03. What is the ratio of the Taxes (in $) in Croatia in 1999 to that in 2002?
Your answer should be very brief. 0.85. What is the ratio of the Taxes (in $) of Myanmar in 1999 to that in 2002?
Your answer should be very brief. 0.54. What is the ratio of the Taxes (in $) in Sri Lanka in 1999 to that in 2002?
Provide a short and direct response. 0.75. What is the ratio of the Taxes (in $) of Angola in 1999 to that in 2003?
Your answer should be compact. 0.01. What is the ratio of the Taxes (in $) in Croatia in 1999 to that in 2003?
Keep it short and to the point. 0.8. What is the ratio of the Taxes (in $) in Myanmar in 1999 to that in 2003?
Offer a very short reply. 0.35. What is the ratio of the Taxes (in $) of Sri Lanka in 1999 to that in 2003?
Make the answer very short. 0.72. What is the ratio of the Taxes (in $) in Angola in 1999 to that in 2004?
Your answer should be very brief. 0.01. What is the ratio of the Taxes (in $) of Croatia in 1999 to that in 2004?
Your response must be concise. 0.77. What is the ratio of the Taxes (in $) of Myanmar in 1999 to that in 2004?
Provide a short and direct response. 0.2. What is the ratio of the Taxes (in $) in Sri Lanka in 1999 to that in 2004?
Your response must be concise. 0.59. What is the ratio of the Taxes (in $) in Angola in 1999 to that in 2005?
Make the answer very short. 0.01. What is the ratio of the Taxes (in $) of Croatia in 1999 to that in 2005?
Your answer should be very brief. 0.72. What is the ratio of the Taxes (in $) in Myanmar in 1999 to that in 2005?
Your response must be concise. 0.13. What is the ratio of the Taxes (in $) in Sri Lanka in 1999 to that in 2005?
Give a very brief answer. 0.49. What is the ratio of the Taxes (in $) in Angola in 2000 to that in 2001?
Provide a short and direct response. 0.59. What is the ratio of the Taxes (in $) in Croatia in 2000 to that in 2001?
Make the answer very short. 0.99. What is the ratio of the Taxes (in $) of Myanmar in 2000 to that in 2001?
Provide a short and direct response. 0.95. What is the ratio of the Taxes (in $) of Sri Lanka in 2000 to that in 2001?
Provide a succinct answer. 0.89. What is the ratio of the Taxes (in $) in Angola in 2000 to that in 2002?
Keep it short and to the point. 0.26. What is the ratio of the Taxes (in $) in Croatia in 2000 to that in 2002?
Your answer should be compact. 0.88. What is the ratio of the Taxes (in $) in Myanmar in 2000 to that in 2002?
Ensure brevity in your answer.  0.67. What is the ratio of the Taxes (in $) of Sri Lanka in 2000 to that in 2002?
Give a very brief answer. 0.82. What is the ratio of the Taxes (in $) in Angola in 2000 to that in 2003?
Your answer should be very brief. 0.12. What is the ratio of the Taxes (in $) of Croatia in 2000 to that in 2003?
Make the answer very short. 0.83. What is the ratio of the Taxes (in $) in Myanmar in 2000 to that in 2003?
Your answer should be very brief. 0.44. What is the ratio of the Taxes (in $) of Sri Lanka in 2000 to that in 2003?
Keep it short and to the point. 0.79. What is the ratio of the Taxes (in $) in Angola in 2000 to that in 2004?
Give a very brief answer. 0.08. What is the ratio of the Taxes (in $) of Croatia in 2000 to that in 2004?
Ensure brevity in your answer.  0.8. What is the ratio of the Taxes (in $) of Myanmar in 2000 to that in 2004?
Offer a terse response. 0.25. What is the ratio of the Taxes (in $) in Sri Lanka in 2000 to that in 2004?
Offer a very short reply. 0.65. What is the ratio of the Taxes (in $) of Angola in 2000 to that in 2005?
Offer a very short reply. 0.06. What is the ratio of the Taxes (in $) of Croatia in 2000 to that in 2005?
Offer a terse response. 0.75. What is the ratio of the Taxes (in $) in Myanmar in 2000 to that in 2005?
Provide a succinct answer. 0.16. What is the ratio of the Taxes (in $) of Sri Lanka in 2000 to that in 2005?
Provide a succinct answer. 0.54. What is the ratio of the Taxes (in $) in Angola in 2001 to that in 2002?
Provide a succinct answer. 0.43. What is the ratio of the Taxes (in $) in Croatia in 2001 to that in 2002?
Keep it short and to the point. 0.9. What is the ratio of the Taxes (in $) in Myanmar in 2001 to that in 2002?
Make the answer very short. 0.71. What is the ratio of the Taxes (in $) of Sri Lanka in 2001 to that in 2002?
Make the answer very short. 0.93. What is the ratio of the Taxes (in $) in Angola in 2001 to that in 2003?
Offer a very short reply. 0.21. What is the ratio of the Taxes (in $) of Croatia in 2001 to that in 2003?
Ensure brevity in your answer.  0.85. What is the ratio of the Taxes (in $) of Myanmar in 2001 to that in 2003?
Give a very brief answer. 0.47. What is the ratio of the Taxes (in $) of Sri Lanka in 2001 to that in 2003?
Your response must be concise. 0.89. What is the ratio of the Taxes (in $) in Angola in 2001 to that in 2004?
Your response must be concise. 0.14. What is the ratio of the Taxes (in $) in Croatia in 2001 to that in 2004?
Offer a terse response. 0.81. What is the ratio of the Taxes (in $) of Myanmar in 2001 to that in 2004?
Your answer should be compact. 0.27. What is the ratio of the Taxes (in $) in Sri Lanka in 2001 to that in 2004?
Ensure brevity in your answer.  0.73. What is the ratio of the Taxes (in $) of Angola in 2001 to that in 2005?
Provide a succinct answer. 0.09. What is the ratio of the Taxes (in $) of Croatia in 2001 to that in 2005?
Keep it short and to the point. 0.76. What is the ratio of the Taxes (in $) of Myanmar in 2001 to that in 2005?
Give a very brief answer. 0.17. What is the ratio of the Taxes (in $) in Sri Lanka in 2001 to that in 2005?
Ensure brevity in your answer.  0.61. What is the ratio of the Taxes (in $) of Angola in 2002 to that in 2003?
Ensure brevity in your answer.  0.48. What is the ratio of the Taxes (in $) in Croatia in 2002 to that in 2003?
Your answer should be compact. 0.94. What is the ratio of the Taxes (in $) in Myanmar in 2002 to that in 2003?
Make the answer very short. 0.66. What is the ratio of the Taxes (in $) in Sri Lanka in 2002 to that in 2003?
Keep it short and to the point. 0.96. What is the ratio of the Taxes (in $) in Angola in 2002 to that in 2004?
Your answer should be compact. 0.33. What is the ratio of the Taxes (in $) in Croatia in 2002 to that in 2004?
Offer a very short reply. 0.91. What is the ratio of the Taxes (in $) in Myanmar in 2002 to that in 2004?
Provide a short and direct response. 0.38. What is the ratio of the Taxes (in $) of Sri Lanka in 2002 to that in 2004?
Your answer should be compact. 0.79. What is the ratio of the Taxes (in $) in Angola in 2002 to that in 2005?
Make the answer very short. 0.22. What is the ratio of the Taxes (in $) of Croatia in 2002 to that in 2005?
Give a very brief answer. 0.85. What is the ratio of the Taxes (in $) of Myanmar in 2002 to that in 2005?
Offer a terse response. 0.24. What is the ratio of the Taxes (in $) in Sri Lanka in 2002 to that in 2005?
Offer a very short reply. 0.66. What is the ratio of the Taxes (in $) in Angola in 2003 to that in 2004?
Ensure brevity in your answer.  0.68. What is the ratio of the Taxes (in $) in Croatia in 2003 to that in 2004?
Your response must be concise. 0.96. What is the ratio of the Taxes (in $) in Myanmar in 2003 to that in 2004?
Your answer should be very brief. 0.57. What is the ratio of the Taxes (in $) in Sri Lanka in 2003 to that in 2004?
Ensure brevity in your answer.  0.82. What is the ratio of the Taxes (in $) of Angola in 2003 to that in 2005?
Offer a terse response. 0.45. What is the ratio of the Taxes (in $) in Croatia in 2003 to that in 2005?
Your response must be concise. 0.9. What is the ratio of the Taxes (in $) in Myanmar in 2003 to that in 2005?
Provide a short and direct response. 0.36. What is the ratio of the Taxes (in $) in Sri Lanka in 2003 to that in 2005?
Provide a short and direct response. 0.69. What is the ratio of the Taxes (in $) in Angola in 2004 to that in 2005?
Give a very brief answer. 0.67. What is the ratio of the Taxes (in $) in Croatia in 2004 to that in 2005?
Keep it short and to the point. 0.93. What is the ratio of the Taxes (in $) of Myanmar in 2004 to that in 2005?
Provide a succinct answer. 0.62. What is the ratio of the Taxes (in $) of Sri Lanka in 2004 to that in 2005?
Your answer should be compact. 0.84. What is the difference between the highest and the second highest Taxes (in $) in Angola?
Provide a succinct answer. 2.14e+11. What is the difference between the highest and the second highest Taxes (in $) of Croatia?
Make the answer very short. 3.62e+09. What is the difference between the highest and the second highest Taxes (in $) of Myanmar?
Your answer should be very brief. 1.80e+11. What is the difference between the highest and the second highest Taxes (in $) of Sri Lanka?
Provide a succinct answer. 5.53e+1. What is the difference between the highest and the lowest Taxes (in $) in Angola?
Your response must be concise. 6.46e+11. What is the difference between the highest and the lowest Taxes (in $) in Croatia?
Offer a terse response. 1.51e+1. What is the difference between the highest and the lowest Taxes (in $) in Myanmar?
Make the answer very short. 4.17e+11. What is the difference between the highest and the lowest Taxes (in $) in Sri Lanka?
Make the answer very short. 1.71e+11. 